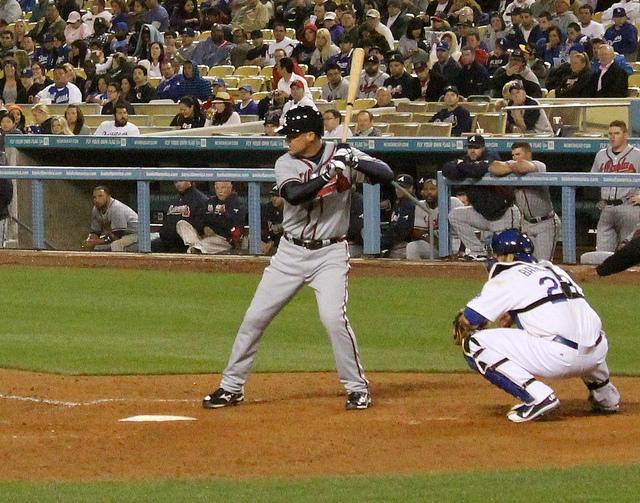How many people can you see?
Give a very brief answer. 7. 